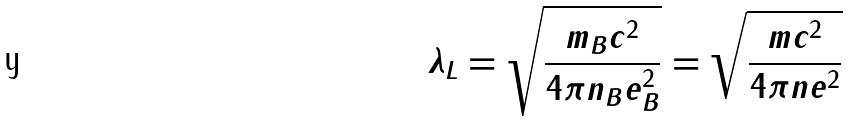<formula> <loc_0><loc_0><loc_500><loc_500>\lambda _ { L } = \sqrt { \frac { m _ { B } c ^ { 2 } } { 4 \pi n _ { B } e _ { B } ^ { 2 } } } = \sqrt { \frac { m c ^ { 2 } } { 4 \pi n e ^ { 2 } } }</formula> 